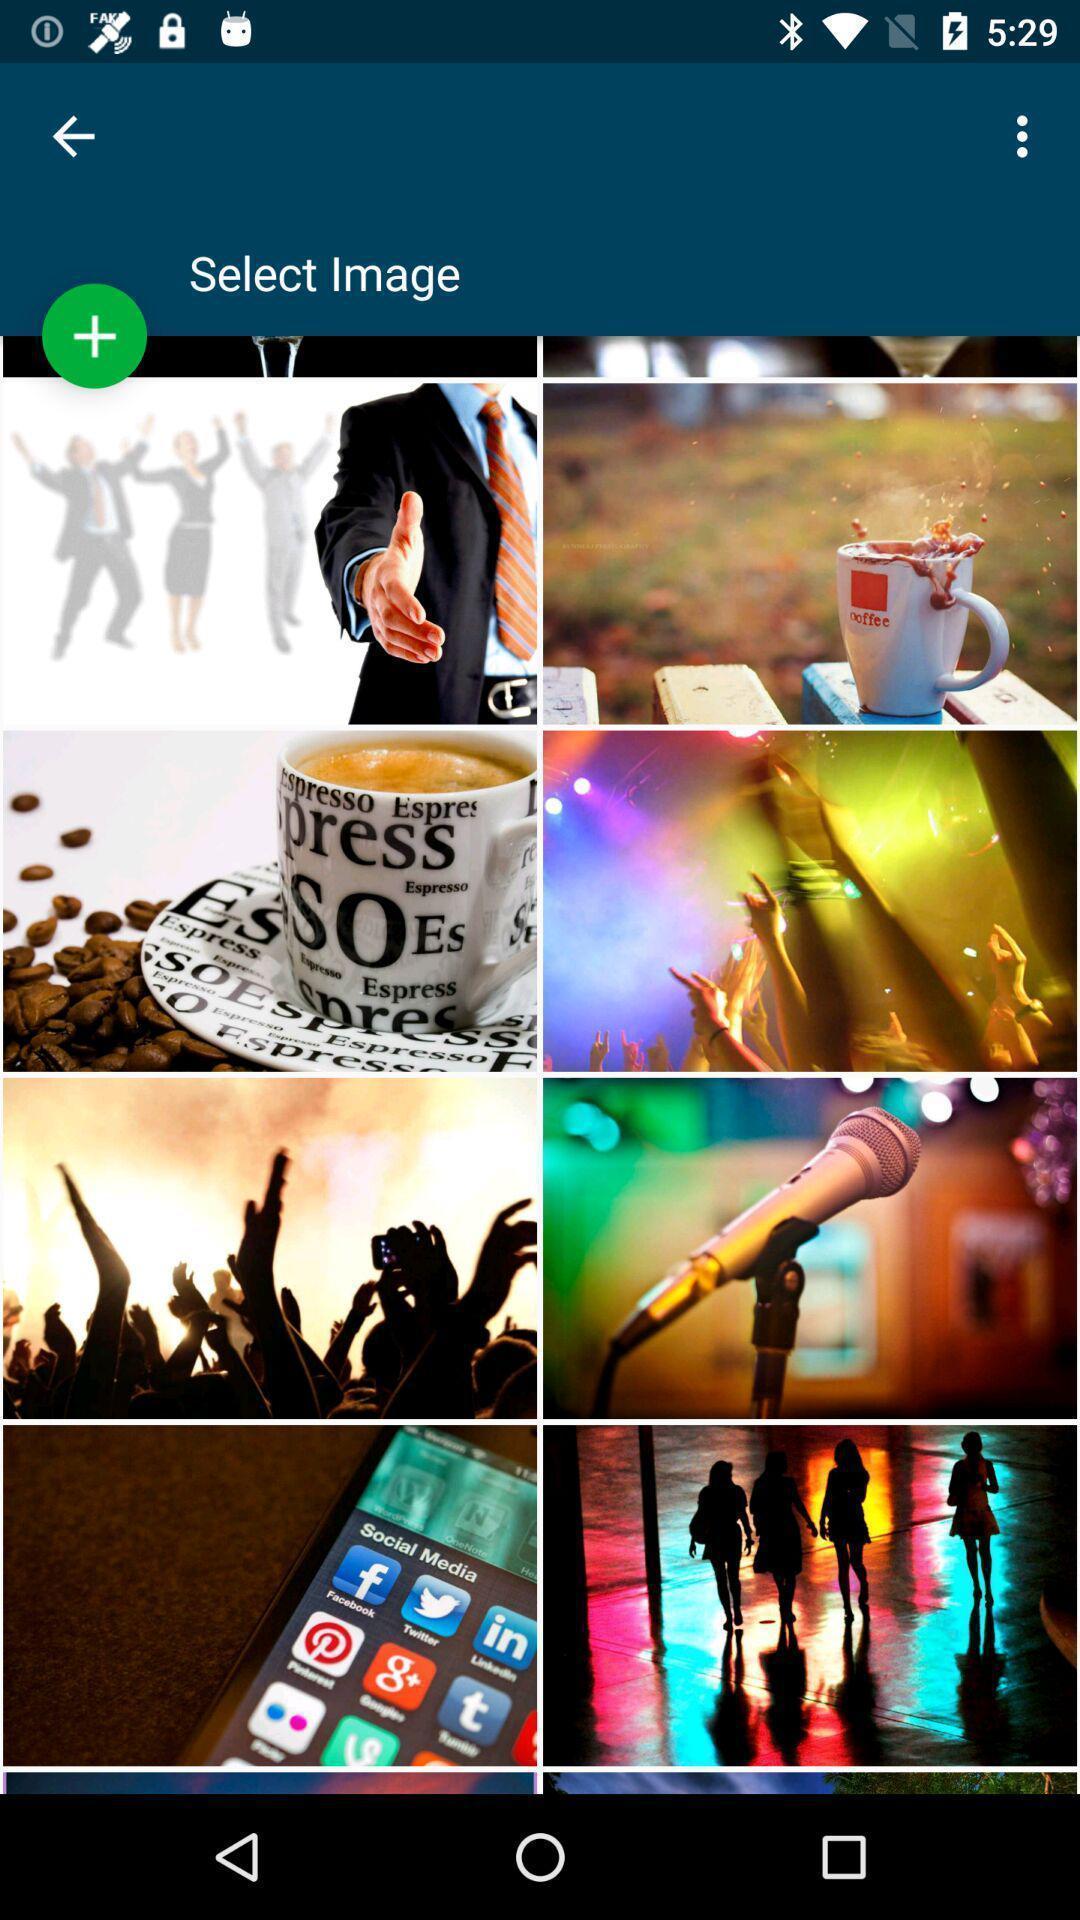Summarize the main components in this picture. Screen displaying the multiple images. 